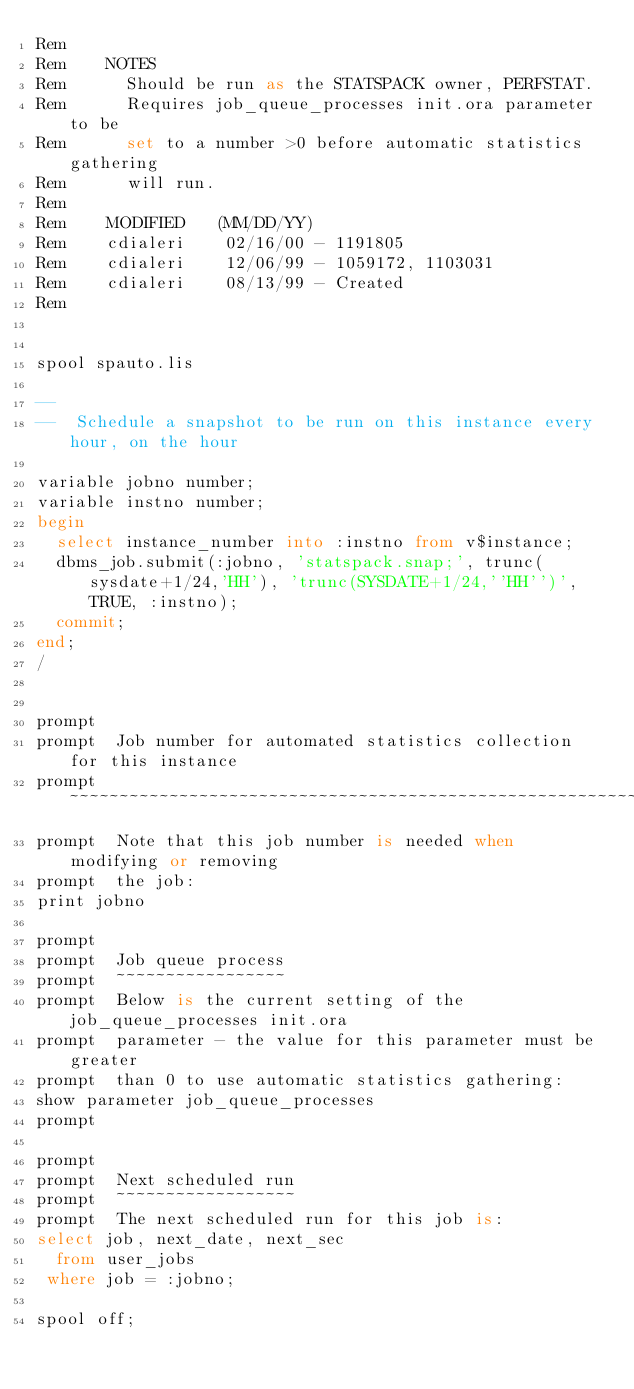<code> <loc_0><loc_0><loc_500><loc_500><_SQL_>Rem
Rem    NOTES
Rem      Should be run as the STATSPACK owner, PERFSTAT.
Rem      Requires job_queue_processes init.ora parameter to be
Rem      set to a number >0 before automatic statistics gathering
Rem      will run.
Rem
Rem    MODIFIED   (MM/DD/YY)
Rem    cdialeri    02/16/00 - 1191805
Rem    cdialeri    12/06/99 - 1059172, 1103031
Rem    cdialeri    08/13/99 - Created
Rem


spool spauto.lis

--
--  Schedule a snapshot to be run on this instance every hour, on the hour

variable jobno number;
variable instno number;
begin
  select instance_number into :instno from v$instance;
  dbms_job.submit(:jobno, 'statspack.snap;', trunc(sysdate+1/24,'HH'), 'trunc(SYSDATE+1/24,''HH'')', TRUE, :instno);
  commit;
end;
/


prompt
prompt  Job number for automated statistics collection for this instance
prompt  ~~~~~~~~~~~~~~~~~~~~~~~~~~~~~~~~~~~~~~~~~~~~~~~~~~~~~~~~~~~~~~~~
prompt  Note that this job number is needed when modifying or removing
prompt  the job:
print jobno

prompt
prompt  Job queue process
prompt  ~~~~~~~~~~~~~~~~~
prompt  Below is the current setting of the job_queue_processes init.ora
prompt  parameter - the value for this parameter must be greater 
prompt  than 0 to use automatic statistics gathering:
show parameter job_queue_processes
prompt

prompt
prompt  Next scheduled run
prompt  ~~~~~~~~~~~~~~~~~~
prompt  The next scheduled run for this job is:
select job, next_date, next_sec
  from user_jobs
 where job = :jobno;

spool off;
</code> 